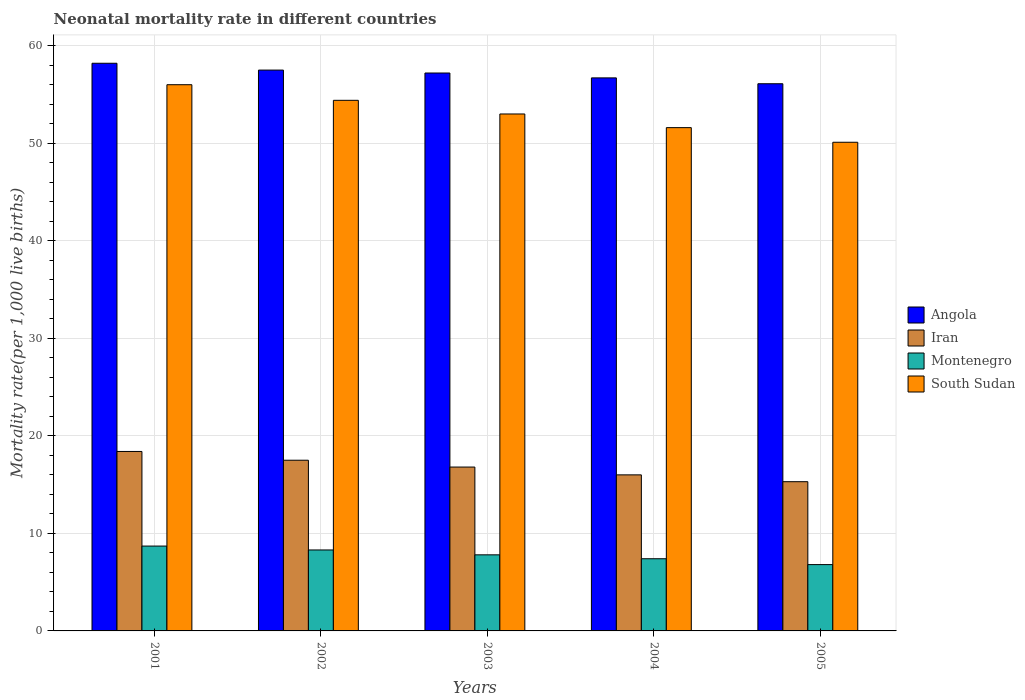How many different coloured bars are there?
Make the answer very short. 4. Are the number of bars per tick equal to the number of legend labels?
Give a very brief answer. Yes. Are the number of bars on each tick of the X-axis equal?
Offer a very short reply. Yes. How many bars are there on the 5th tick from the right?
Your answer should be very brief. 4. What is the neonatal mortality rate in Angola in 2002?
Give a very brief answer. 57.5. Across all years, what is the minimum neonatal mortality rate in South Sudan?
Your response must be concise. 50.1. In which year was the neonatal mortality rate in Iran maximum?
Give a very brief answer. 2001. What is the total neonatal mortality rate in South Sudan in the graph?
Ensure brevity in your answer.  265.1. What is the difference between the neonatal mortality rate in Montenegro in 2001 and that in 2002?
Provide a succinct answer. 0.4. What is the difference between the neonatal mortality rate in Montenegro in 2003 and the neonatal mortality rate in South Sudan in 2002?
Your answer should be very brief. -46.6. What is the average neonatal mortality rate in Angola per year?
Keep it short and to the point. 57.14. In the year 2001, what is the difference between the neonatal mortality rate in Angola and neonatal mortality rate in Montenegro?
Your response must be concise. 49.5. In how many years, is the neonatal mortality rate in Montenegro greater than 46?
Provide a succinct answer. 0. What is the ratio of the neonatal mortality rate in Montenegro in 2001 to that in 2005?
Your response must be concise. 1.28. What is the difference between the highest and the second highest neonatal mortality rate in South Sudan?
Give a very brief answer. 1.6. What is the difference between the highest and the lowest neonatal mortality rate in Montenegro?
Ensure brevity in your answer.  1.9. Is the sum of the neonatal mortality rate in Iran in 2002 and 2003 greater than the maximum neonatal mortality rate in South Sudan across all years?
Your answer should be very brief. No. Is it the case that in every year, the sum of the neonatal mortality rate in Angola and neonatal mortality rate in Iran is greater than the sum of neonatal mortality rate in Montenegro and neonatal mortality rate in South Sudan?
Your answer should be very brief. Yes. What does the 4th bar from the left in 2001 represents?
Give a very brief answer. South Sudan. What does the 2nd bar from the right in 2003 represents?
Your answer should be very brief. Montenegro. How many bars are there?
Make the answer very short. 20. Are all the bars in the graph horizontal?
Ensure brevity in your answer.  No. How many years are there in the graph?
Offer a very short reply. 5. How many legend labels are there?
Give a very brief answer. 4. How are the legend labels stacked?
Give a very brief answer. Vertical. What is the title of the graph?
Ensure brevity in your answer.  Neonatal mortality rate in different countries. What is the label or title of the X-axis?
Provide a succinct answer. Years. What is the label or title of the Y-axis?
Your answer should be very brief. Mortality rate(per 1,0 live births). What is the Mortality rate(per 1,000 live births) in Angola in 2001?
Offer a terse response. 58.2. What is the Mortality rate(per 1,000 live births) in Iran in 2001?
Your answer should be compact. 18.4. What is the Mortality rate(per 1,000 live births) in Angola in 2002?
Ensure brevity in your answer.  57.5. What is the Mortality rate(per 1,000 live births) of Iran in 2002?
Ensure brevity in your answer.  17.5. What is the Mortality rate(per 1,000 live births) in Montenegro in 2002?
Ensure brevity in your answer.  8.3. What is the Mortality rate(per 1,000 live births) of South Sudan in 2002?
Your answer should be compact. 54.4. What is the Mortality rate(per 1,000 live births) of Angola in 2003?
Offer a terse response. 57.2. What is the Mortality rate(per 1,000 live births) of Iran in 2003?
Keep it short and to the point. 16.8. What is the Mortality rate(per 1,000 live births) in Angola in 2004?
Your answer should be very brief. 56.7. What is the Mortality rate(per 1,000 live births) in Montenegro in 2004?
Provide a succinct answer. 7.4. What is the Mortality rate(per 1,000 live births) of South Sudan in 2004?
Keep it short and to the point. 51.6. What is the Mortality rate(per 1,000 live births) of Angola in 2005?
Your answer should be very brief. 56.1. What is the Mortality rate(per 1,000 live births) in Iran in 2005?
Give a very brief answer. 15.3. What is the Mortality rate(per 1,000 live births) of South Sudan in 2005?
Offer a terse response. 50.1. Across all years, what is the maximum Mortality rate(per 1,000 live births) in Angola?
Offer a very short reply. 58.2. Across all years, what is the maximum Mortality rate(per 1,000 live births) of Iran?
Your answer should be very brief. 18.4. Across all years, what is the minimum Mortality rate(per 1,000 live births) in Angola?
Keep it short and to the point. 56.1. Across all years, what is the minimum Mortality rate(per 1,000 live births) of Montenegro?
Ensure brevity in your answer.  6.8. Across all years, what is the minimum Mortality rate(per 1,000 live births) in South Sudan?
Offer a very short reply. 50.1. What is the total Mortality rate(per 1,000 live births) in Angola in the graph?
Ensure brevity in your answer.  285.7. What is the total Mortality rate(per 1,000 live births) in South Sudan in the graph?
Give a very brief answer. 265.1. What is the difference between the Mortality rate(per 1,000 live births) of Angola in 2001 and that in 2002?
Your answer should be very brief. 0.7. What is the difference between the Mortality rate(per 1,000 live births) in Montenegro in 2001 and that in 2002?
Your answer should be compact. 0.4. What is the difference between the Mortality rate(per 1,000 live births) of South Sudan in 2001 and that in 2002?
Ensure brevity in your answer.  1.6. What is the difference between the Mortality rate(per 1,000 live births) in Angola in 2001 and that in 2003?
Offer a terse response. 1. What is the difference between the Mortality rate(per 1,000 live births) in Iran in 2001 and that in 2003?
Keep it short and to the point. 1.6. What is the difference between the Mortality rate(per 1,000 live births) in Iran in 2001 and that in 2004?
Ensure brevity in your answer.  2.4. What is the difference between the Mortality rate(per 1,000 live births) in Montenegro in 2001 and that in 2004?
Your answer should be compact. 1.3. What is the difference between the Mortality rate(per 1,000 live births) of South Sudan in 2001 and that in 2004?
Your answer should be compact. 4.4. What is the difference between the Mortality rate(per 1,000 live births) in Angola in 2002 and that in 2003?
Your response must be concise. 0.3. What is the difference between the Mortality rate(per 1,000 live births) in Iran in 2002 and that in 2004?
Ensure brevity in your answer.  1.5. What is the difference between the Mortality rate(per 1,000 live births) in Montenegro in 2002 and that in 2004?
Give a very brief answer. 0.9. What is the difference between the Mortality rate(per 1,000 live births) of Montenegro in 2002 and that in 2005?
Keep it short and to the point. 1.5. What is the difference between the Mortality rate(per 1,000 live births) in Iran in 2003 and that in 2004?
Provide a short and direct response. 0.8. What is the difference between the Mortality rate(per 1,000 live births) in Iran in 2003 and that in 2005?
Your answer should be compact. 1.5. What is the difference between the Mortality rate(per 1,000 live births) of South Sudan in 2003 and that in 2005?
Offer a very short reply. 2.9. What is the difference between the Mortality rate(per 1,000 live births) of Angola in 2004 and that in 2005?
Ensure brevity in your answer.  0.6. What is the difference between the Mortality rate(per 1,000 live births) in South Sudan in 2004 and that in 2005?
Provide a succinct answer. 1.5. What is the difference between the Mortality rate(per 1,000 live births) in Angola in 2001 and the Mortality rate(per 1,000 live births) in Iran in 2002?
Make the answer very short. 40.7. What is the difference between the Mortality rate(per 1,000 live births) in Angola in 2001 and the Mortality rate(per 1,000 live births) in Montenegro in 2002?
Ensure brevity in your answer.  49.9. What is the difference between the Mortality rate(per 1,000 live births) of Iran in 2001 and the Mortality rate(per 1,000 live births) of South Sudan in 2002?
Provide a short and direct response. -36. What is the difference between the Mortality rate(per 1,000 live births) in Montenegro in 2001 and the Mortality rate(per 1,000 live births) in South Sudan in 2002?
Your answer should be compact. -45.7. What is the difference between the Mortality rate(per 1,000 live births) in Angola in 2001 and the Mortality rate(per 1,000 live births) in Iran in 2003?
Provide a succinct answer. 41.4. What is the difference between the Mortality rate(per 1,000 live births) in Angola in 2001 and the Mortality rate(per 1,000 live births) in Montenegro in 2003?
Offer a very short reply. 50.4. What is the difference between the Mortality rate(per 1,000 live births) in Iran in 2001 and the Mortality rate(per 1,000 live births) in Montenegro in 2003?
Your answer should be compact. 10.6. What is the difference between the Mortality rate(per 1,000 live births) in Iran in 2001 and the Mortality rate(per 1,000 live births) in South Sudan in 2003?
Offer a very short reply. -34.6. What is the difference between the Mortality rate(per 1,000 live births) in Montenegro in 2001 and the Mortality rate(per 1,000 live births) in South Sudan in 2003?
Make the answer very short. -44.3. What is the difference between the Mortality rate(per 1,000 live births) of Angola in 2001 and the Mortality rate(per 1,000 live births) of Iran in 2004?
Offer a terse response. 42.2. What is the difference between the Mortality rate(per 1,000 live births) of Angola in 2001 and the Mortality rate(per 1,000 live births) of Montenegro in 2004?
Provide a short and direct response. 50.8. What is the difference between the Mortality rate(per 1,000 live births) in Angola in 2001 and the Mortality rate(per 1,000 live births) in South Sudan in 2004?
Offer a terse response. 6.6. What is the difference between the Mortality rate(per 1,000 live births) in Iran in 2001 and the Mortality rate(per 1,000 live births) in Montenegro in 2004?
Offer a terse response. 11. What is the difference between the Mortality rate(per 1,000 live births) of Iran in 2001 and the Mortality rate(per 1,000 live births) of South Sudan in 2004?
Your response must be concise. -33.2. What is the difference between the Mortality rate(per 1,000 live births) of Montenegro in 2001 and the Mortality rate(per 1,000 live births) of South Sudan in 2004?
Make the answer very short. -42.9. What is the difference between the Mortality rate(per 1,000 live births) of Angola in 2001 and the Mortality rate(per 1,000 live births) of Iran in 2005?
Offer a terse response. 42.9. What is the difference between the Mortality rate(per 1,000 live births) of Angola in 2001 and the Mortality rate(per 1,000 live births) of Montenegro in 2005?
Offer a terse response. 51.4. What is the difference between the Mortality rate(per 1,000 live births) of Angola in 2001 and the Mortality rate(per 1,000 live births) of South Sudan in 2005?
Provide a short and direct response. 8.1. What is the difference between the Mortality rate(per 1,000 live births) in Iran in 2001 and the Mortality rate(per 1,000 live births) in South Sudan in 2005?
Make the answer very short. -31.7. What is the difference between the Mortality rate(per 1,000 live births) in Montenegro in 2001 and the Mortality rate(per 1,000 live births) in South Sudan in 2005?
Your answer should be very brief. -41.4. What is the difference between the Mortality rate(per 1,000 live births) of Angola in 2002 and the Mortality rate(per 1,000 live births) of Iran in 2003?
Offer a very short reply. 40.7. What is the difference between the Mortality rate(per 1,000 live births) of Angola in 2002 and the Mortality rate(per 1,000 live births) of Montenegro in 2003?
Provide a succinct answer. 49.7. What is the difference between the Mortality rate(per 1,000 live births) of Iran in 2002 and the Mortality rate(per 1,000 live births) of South Sudan in 2003?
Offer a very short reply. -35.5. What is the difference between the Mortality rate(per 1,000 live births) in Montenegro in 2002 and the Mortality rate(per 1,000 live births) in South Sudan in 2003?
Your answer should be very brief. -44.7. What is the difference between the Mortality rate(per 1,000 live births) of Angola in 2002 and the Mortality rate(per 1,000 live births) of Iran in 2004?
Offer a terse response. 41.5. What is the difference between the Mortality rate(per 1,000 live births) of Angola in 2002 and the Mortality rate(per 1,000 live births) of Montenegro in 2004?
Your response must be concise. 50.1. What is the difference between the Mortality rate(per 1,000 live births) in Iran in 2002 and the Mortality rate(per 1,000 live births) in Montenegro in 2004?
Provide a succinct answer. 10.1. What is the difference between the Mortality rate(per 1,000 live births) of Iran in 2002 and the Mortality rate(per 1,000 live births) of South Sudan in 2004?
Your response must be concise. -34.1. What is the difference between the Mortality rate(per 1,000 live births) in Montenegro in 2002 and the Mortality rate(per 1,000 live births) in South Sudan in 2004?
Ensure brevity in your answer.  -43.3. What is the difference between the Mortality rate(per 1,000 live births) in Angola in 2002 and the Mortality rate(per 1,000 live births) in Iran in 2005?
Your answer should be compact. 42.2. What is the difference between the Mortality rate(per 1,000 live births) of Angola in 2002 and the Mortality rate(per 1,000 live births) of Montenegro in 2005?
Your response must be concise. 50.7. What is the difference between the Mortality rate(per 1,000 live births) in Iran in 2002 and the Mortality rate(per 1,000 live births) in Montenegro in 2005?
Give a very brief answer. 10.7. What is the difference between the Mortality rate(per 1,000 live births) in Iran in 2002 and the Mortality rate(per 1,000 live births) in South Sudan in 2005?
Keep it short and to the point. -32.6. What is the difference between the Mortality rate(per 1,000 live births) of Montenegro in 2002 and the Mortality rate(per 1,000 live births) of South Sudan in 2005?
Your response must be concise. -41.8. What is the difference between the Mortality rate(per 1,000 live births) of Angola in 2003 and the Mortality rate(per 1,000 live births) of Iran in 2004?
Provide a succinct answer. 41.2. What is the difference between the Mortality rate(per 1,000 live births) in Angola in 2003 and the Mortality rate(per 1,000 live births) in Montenegro in 2004?
Ensure brevity in your answer.  49.8. What is the difference between the Mortality rate(per 1,000 live births) in Angola in 2003 and the Mortality rate(per 1,000 live births) in South Sudan in 2004?
Ensure brevity in your answer.  5.6. What is the difference between the Mortality rate(per 1,000 live births) in Iran in 2003 and the Mortality rate(per 1,000 live births) in Montenegro in 2004?
Provide a short and direct response. 9.4. What is the difference between the Mortality rate(per 1,000 live births) of Iran in 2003 and the Mortality rate(per 1,000 live births) of South Sudan in 2004?
Ensure brevity in your answer.  -34.8. What is the difference between the Mortality rate(per 1,000 live births) of Montenegro in 2003 and the Mortality rate(per 1,000 live births) of South Sudan in 2004?
Offer a terse response. -43.8. What is the difference between the Mortality rate(per 1,000 live births) in Angola in 2003 and the Mortality rate(per 1,000 live births) in Iran in 2005?
Offer a terse response. 41.9. What is the difference between the Mortality rate(per 1,000 live births) in Angola in 2003 and the Mortality rate(per 1,000 live births) in Montenegro in 2005?
Provide a succinct answer. 50.4. What is the difference between the Mortality rate(per 1,000 live births) in Iran in 2003 and the Mortality rate(per 1,000 live births) in Montenegro in 2005?
Ensure brevity in your answer.  10. What is the difference between the Mortality rate(per 1,000 live births) in Iran in 2003 and the Mortality rate(per 1,000 live births) in South Sudan in 2005?
Keep it short and to the point. -33.3. What is the difference between the Mortality rate(per 1,000 live births) of Montenegro in 2003 and the Mortality rate(per 1,000 live births) of South Sudan in 2005?
Ensure brevity in your answer.  -42.3. What is the difference between the Mortality rate(per 1,000 live births) of Angola in 2004 and the Mortality rate(per 1,000 live births) of Iran in 2005?
Make the answer very short. 41.4. What is the difference between the Mortality rate(per 1,000 live births) of Angola in 2004 and the Mortality rate(per 1,000 live births) of Montenegro in 2005?
Provide a succinct answer. 49.9. What is the difference between the Mortality rate(per 1,000 live births) in Angola in 2004 and the Mortality rate(per 1,000 live births) in South Sudan in 2005?
Make the answer very short. 6.6. What is the difference between the Mortality rate(per 1,000 live births) in Iran in 2004 and the Mortality rate(per 1,000 live births) in Montenegro in 2005?
Give a very brief answer. 9.2. What is the difference between the Mortality rate(per 1,000 live births) of Iran in 2004 and the Mortality rate(per 1,000 live births) of South Sudan in 2005?
Your answer should be very brief. -34.1. What is the difference between the Mortality rate(per 1,000 live births) in Montenegro in 2004 and the Mortality rate(per 1,000 live births) in South Sudan in 2005?
Your response must be concise. -42.7. What is the average Mortality rate(per 1,000 live births) of Angola per year?
Offer a terse response. 57.14. What is the average Mortality rate(per 1,000 live births) in Iran per year?
Give a very brief answer. 16.8. What is the average Mortality rate(per 1,000 live births) of Montenegro per year?
Offer a very short reply. 7.8. What is the average Mortality rate(per 1,000 live births) in South Sudan per year?
Make the answer very short. 53.02. In the year 2001, what is the difference between the Mortality rate(per 1,000 live births) of Angola and Mortality rate(per 1,000 live births) of Iran?
Ensure brevity in your answer.  39.8. In the year 2001, what is the difference between the Mortality rate(per 1,000 live births) in Angola and Mortality rate(per 1,000 live births) in Montenegro?
Make the answer very short. 49.5. In the year 2001, what is the difference between the Mortality rate(per 1,000 live births) in Iran and Mortality rate(per 1,000 live births) in South Sudan?
Offer a terse response. -37.6. In the year 2001, what is the difference between the Mortality rate(per 1,000 live births) of Montenegro and Mortality rate(per 1,000 live births) of South Sudan?
Your answer should be very brief. -47.3. In the year 2002, what is the difference between the Mortality rate(per 1,000 live births) in Angola and Mortality rate(per 1,000 live births) in Iran?
Give a very brief answer. 40. In the year 2002, what is the difference between the Mortality rate(per 1,000 live births) of Angola and Mortality rate(per 1,000 live births) of Montenegro?
Provide a succinct answer. 49.2. In the year 2002, what is the difference between the Mortality rate(per 1,000 live births) of Angola and Mortality rate(per 1,000 live births) of South Sudan?
Make the answer very short. 3.1. In the year 2002, what is the difference between the Mortality rate(per 1,000 live births) in Iran and Mortality rate(per 1,000 live births) in Montenegro?
Provide a short and direct response. 9.2. In the year 2002, what is the difference between the Mortality rate(per 1,000 live births) of Iran and Mortality rate(per 1,000 live births) of South Sudan?
Make the answer very short. -36.9. In the year 2002, what is the difference between the Mortality rate(per 1,000 live births) in Montenegro and Mortality rate(per 1,000 live births) in South Sudan?
Keep it short and to the point. -46.1. In the year 2003, what is the difference between the Mortality rate(per 1,000 live births) in Angola and Mortality rate(per 1,000 live births) in Iran?
Your answer should be very brief. 40.4. In the year 2003, what is the difference between the Mortality rate(per 1,000 live births) of Angola and Mortality rate(per 1,000 live births) of Montenegro?
Your answer should be very brief. 49.4. In the year 2003, what is the difference between the Mortality rate(per 1,000 live births) of Iran and Mortality rate(per 1,000 live births) of Montenegro?
Your response must be concise. 9. In the year 2003, what is the difference between the Mortality rate(per 1,000 live births) in Iran and Mortality rate(per 1,000 live births) in South Sudan?
Offer a terse response. -36.2. In the year 2003, what is the difference between the Mortality rate(per 1,000 live births) in Montenegro and Mortality rate(per 1,000 live births) in South Sudan?
Make the answer very short. -45.2. In the year 2004, what is the difference between the Mortality rate(per 1,000 live births) in Angola and Mortality rate(per 1,000 live births) in Iran?
Your response must be concise. 40.7. In the year 2004, what is the difference between the Mortality rate(per 1,000 live births) in Angola and Mortality rate(per 1,000 live births) in Montenegro?
Keep it short and to the point. 49.3. In the year 2004, what is the difference between the Mortality rate(per 1,000 live births) of Angola and Mortality rate(per 1,000 live births) of South Sudan?
Offer a terse response. 5.1. In the year 2004, what is the difference between the Mortality rate(per 1,000 live births) of Iran and Mortality rate(per 1,000 live births) of Montenegro?
Offer a very short reply. 8.6. In the year 2004, what is the difference between the Mortality rate(per 1,000 live births) of Iran and Mortality rate(per 1,000 live births) of South Sudan?
Make the answer very short. -35.6. In the year 2004, what is the difference between the Mortality rate(per 1,000 live births) in Montenegro and Mortality rate(per 1,000 live births) in South Sudan?
Keep it short and to the point. -44.2. In the year 2005, what is the difference between the Mortality rate(per 1,000 live births) in Angola and Mortality rate(per 1,000 live births) in Iran?
Give a very brief answer. 40.8. In the year 2005, what is the difference between the Mortality rate(per 1,000 live births) of Angola and Mortality rate(per 1,000 live births) of Montenegro?
Keep it short and to the point. 49.3. In the year 2005, what is the difference between the Mortality rate(per 1,000 live births) of Angola and Mortality rate(per 1,000 live births) of South Sudan?
Your response must be concise. 6. In the year 2005, what is the difference between the Mortality rate(per 1,000 live births) in Iran and Mortality rate(per 1,000 live births) in Montenegro?
Your response must be concise. 8.5. In the year 2005, what is the difference between the Mortality rate(per 1,000 live births) in Iran and Mortality rate(per 1,000 live births) in South Sudan?
Offer a terse response. -34.8. In the year 2005, what is the difference between the Mortality rate(per 1,000 live births) in Montenegro and Mortality rate(per 1,000 live births) in South Sudan?
Offer a very short reply. -43.3. What is the ratio of the Mortality rate(per 1,000 live births) in Angola in 2001 to that in 2002?
Make the answer very short. 1.01. What is the ratio of the Mortality rate(per 1,000 live births) in Iran in 2001 to that in 2002?
Keep it short and to the point. 1.05. What is the ratio of the Mortality rate(per 1,000 live births) in Montenegro in 2001 to that in 2002?
Your answer should be compact. 1.05. What is the ratio of the Mortality rate(per 1,000 live births) in South Sudan in 2001 to that in 2002?
Provide a succinct answer. 1.03. What is the ratio of the Mortality rate(per 1,000 live births) in Angola in 2001 to that in 2003?
Offer a terse response. 1.02. What is the ratio of the Mortality rate(per 1,000 live births) of Iran in 2001 to that in 2003?
Your response must be concise. 1.1. What is the ratio of the Mortality rate(per 1,000 live births) in Montenegro in 2001 to that in 2003?
Offer a very short reply. 1.12. What is the ratio of the Mortality rate(per 1,000 live births) of South Sudan in 2001 to that in 2003?
Provide a short and direct response. 1.06. What is the ratio of the Mortality rate(per 1,000 live births) in Angola in 2001 to that in 2004?
Keep it short and to the point. 1.03. What is the ratio of the Mortality rate(per 1,000 live births) of Iran in 2001 to that in 2004?
Offer a very short reply. 1.15. What is the ratio of the Mortality rate(per 1,000 live births) of Montenegro in 2001 to that in 2004?
Provide a succinct answer. 1.18. What is the ratio of the Mortality rate(per 1,000 live births) of South Sudan in 2001 to that in 2004?
Provide a succinct answer. 1.09. What is the ratio of the Mortality rate(per 1,000 live births) of Angola in 2001 to that in 2005?
Offer a very short reply. 1.04. What is the ratio of the Mortality rate(per 1,000 live births) of Iran in 2001 to that in 2005?
Give a very brief answer. 1.2. What is the ratio of the Mortality rate(per 1,000 live births) in Montenegro in 2001 to that in 2005?
Keep it short and to the point. 1.28. What is the ratio of the Mortality rate(per 1,000 live births) of South Sudan in 2001 to that in 2005?
Your response must be concise. 1.12. What is the ratio of the Mortality rate(per 1,000 live births) in Iran in 2002 to that in 2003?
Offer a very short reply. 1.04. What is the ratio of the Mortality rate(per 1,000 live births) of Montenegro in 2002 to that in 2003?
Your answer should be compact. 1.06. What is the ratio of the Mortality rate(per 1,000 live births) of South Sudan in 2002 to that in 2003?
Provide a short and direct response. 1.03. What is the ratio of the Mortality rate(per 1,000 live births) of Angola in 2002 to that in 2004?
Keep it short and to the point. 1.01. What is the ratio of the Mortality rate(per 1,000 live births) of Iran in 2002 to that in 2004?
Make the answer very short. 1.09. What is the ratio of the Mortality rate(per 1,000 live births) of Montenegro in 2002 to that in 2004?
Provide a short and direct response. 1.12. What is the ratio of the Mortality rate(per 1,000 live births) in South Sudan in 2002 to that in 2004?
Your answer should be very brief. 1.05. What is the ratio of the Mortality rate(per 1,000 live births) of Iran in 2002 to that in 2005?
Provide a short and direct response. 1.14. What is the ratio of the Mortality rate(per 1,000 live births) in Montenegro in 2002 to that in 2005?
Your answer should be compact. 1.22. What is the ratio of the Mortality rate(per 1,000 live births) of South Sudan in 2002 to that in 2005?
Make the answer very short. 1.09. What is the ratio of the Mortality rate(per 1,000 live births) of Angola in 2003 to that in 2004?
Your answer should be compact. 1.01. What is the ratio of the Mortality rate(per 1,000 live births) of Iran in 2003 to that in 2004?
Offer a very short reply. 1.05. What is the ratio of the Mortality rate(per 1,000 live births) of Montenegro in 2003 to that in 2004?
Provide a succinct answer. 1.05. What is the ratio of the Mortality rate(per 1,000 live births) in South Sudan in 2003 to that in 2004?
Offer a very short reply. 1.03. What is the ratio of the Mortality rate(per 1,000 live births) of Angola in 2003 to that in 2005?
Provide a short and direct response. 1.02. What is the ratio of the Mortality rate(per 1,000 live births) in Iran in 2003 to that in 2005?
Provide a short and direct response. 1.1. What is the ratio of the Mortality rate(per 1,000 live births) in Montenegro in 2003 to that in 2005?
Make the answer very short. 1.15. What is the ratio of the Mortality rate(per 1,000 live births) in South Sudan in 2003 to that in 2005?
Offer a very short reply. 1.06. What is the ratio of the Mortality rate(per 1,000 live births) in Angola in 2004 to that in 2005?
Offer a very short reply. 1.01. What is the ratio of the Mortality rate(per 1,000 live births) of Iran in 2004 to that in 2005?
Your response must be concise. 1.05. What is the ratio of the Mortality rate(per 1,000 live births) of Montenegro in 2004 to that in 2005?
Offer a very short reply. 1.09. What is the ratio of the Mortality rate(per 1,000 live births) in South Sudan in 2004 to that in 2005?
Ensure brevity in your answer.  1.03. What is the difference between the highest and the second highest Mortality rate(per 1,000 live births) in Angola?
Offer a very short reply. 0.7. What is the difference between the highest and the second highest Mortality rate(per 1,000 live births) of Iran?
Ensure brevity in your answer.  0.9. What is the difference between the highest and the lowest Mortality rate(per 1,000 live births) in Iran?
Offer a terse response. 3.1. 